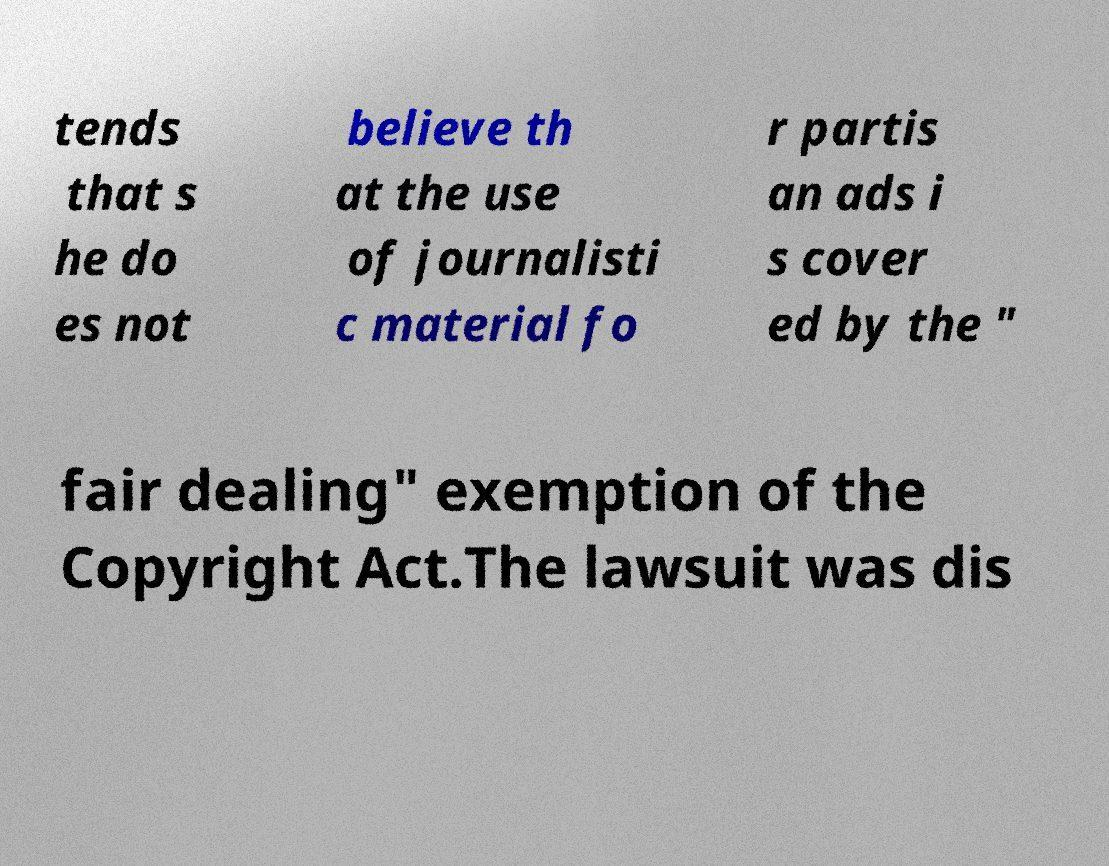Please identify and transcribe the text found in this image. tends that s he do es not believe th at the use of journalisti c material fo r partis an ads i s cover ed by the " fair dealing" exemption of the Copyright Act.The lawsuit was dis 